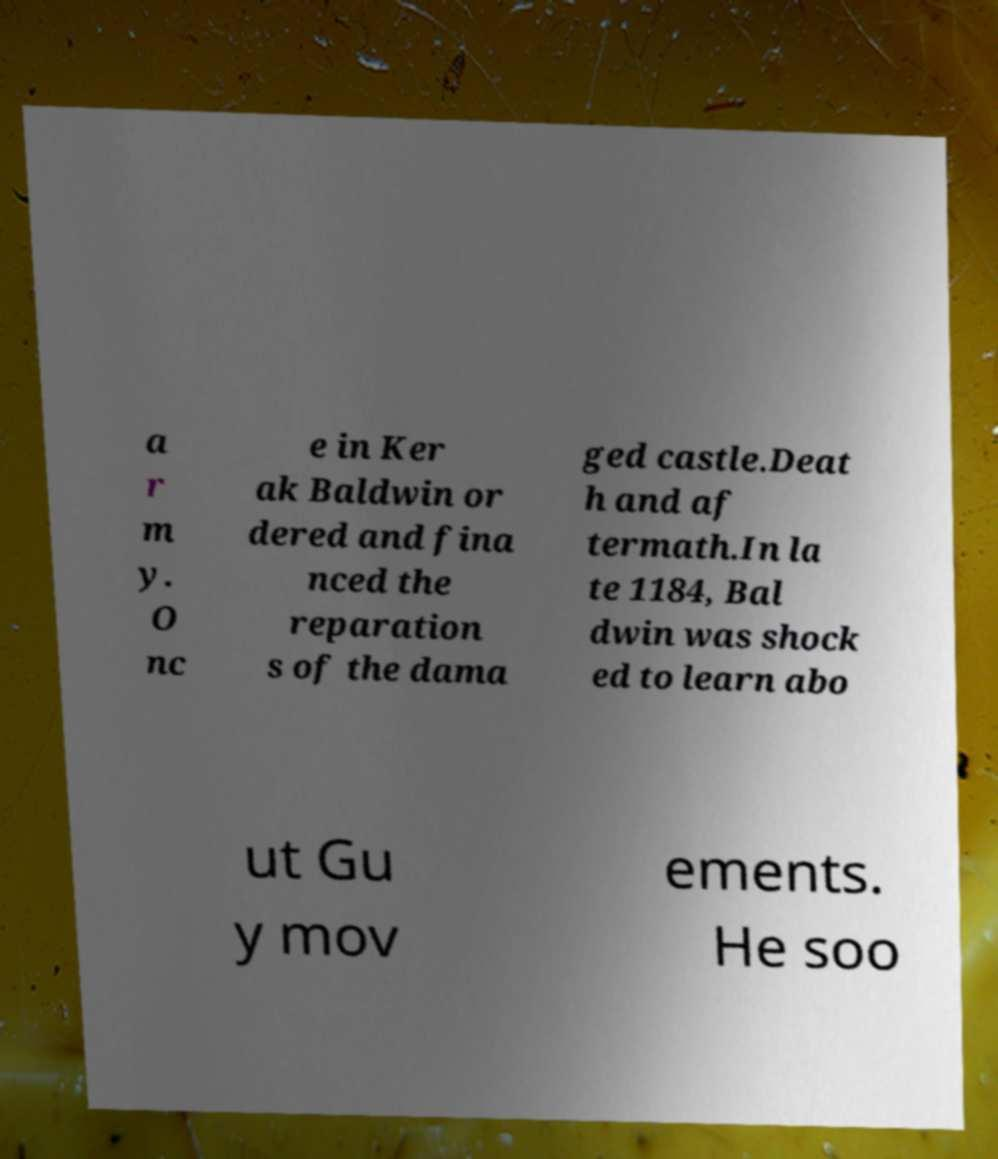Please read and relay the text visible in this image. What does it say? a r m y. O nc e in Ker ak Baldwin or dered and fina nced the reparation s of the dama ged castle.Deat h and af termath.In la te 1184, Bal dwin was shock ed to learn abo ut Gu y mov ements. He soo 